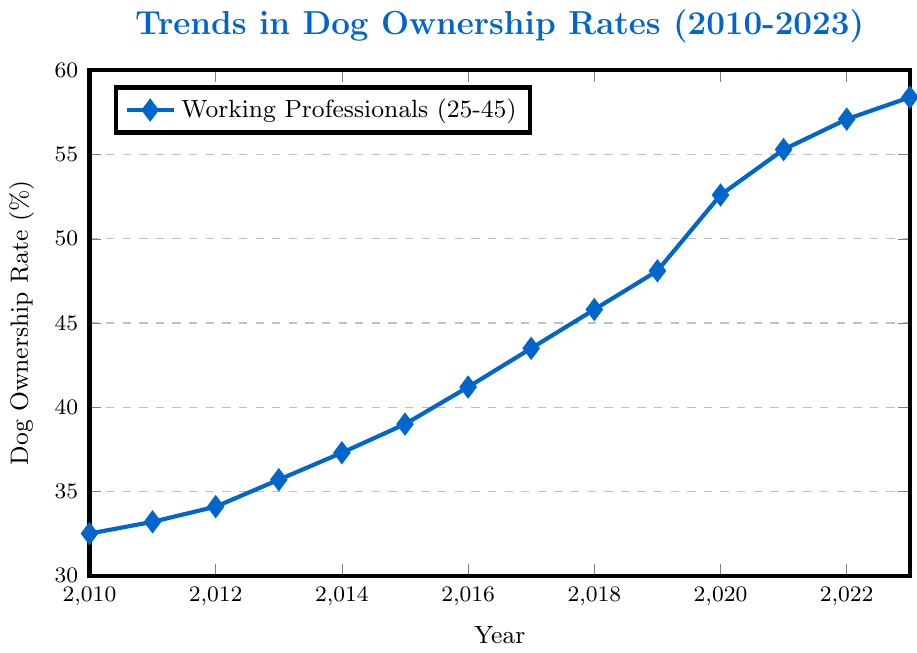what is the highest dog ownership rate recorded between 2010 and 2023? Looking at the y-axis (dog ownership rate) and finding the maximum value on the plotted line, the highest rate is 58.4% in 2023.
Answer: 58.4% Which year experienced the biggest increase in dog ownership rate compared to the previous year? Calculate the year-on-year differences: 33.2 - 32.5 = 0.7 (2010-2011), 34.1 - 33.2 = 0.9 (2011-2012), ..., 58.4 - 57.1 = 1.3 (2022-2023). The largest increase is from 2019 to 2020 with 52.6 - 48.1 = 4.5.
Answer: 2019-2020 How much did the dog ownership rate increase from 2010 to 2023? Subtract the value in 2010 from the value in 2023: 58.4 - 32.5.
Answer: 25.9 In which years did the dog ownership rate exceed 40%? Identify years where the plotted values exceed 40%: from 2016 onwards the values are above 40%.
Answer: 2016-2023 What is the average dog ownership rate over the entire period? Sum all values and divide by the number of years: (32.5 + 33.2 + 34.1 + 35.7 + 37.3 + 39.0 + 41.2 + 43.5 + 45.8 + 48.1 + 52.6 + 55.3 + 57.1 + 58.4) / 14.
Answer: 43.61% Between which consecutive years was the smallest increase in dog ownership rate recorded? Compute the year-on-year differences: 33.2 - 32.5 = 0.7 (2010-2011), 34.1 - 33.2 = 0.9 (2011-2012), ..., 58.4 - 57.1 = 1.3 (2022-2023). The smallest increase is from 2010 to 2011 with 32.5 to 33.2 = 0.7.
Answer: 2010-2011 Did the dog ownership rate rise steadily every year or were there any declines? By examining the plotted trend, the dog ownership rate increases with each passing year without any declines.
Answer: risen steadily How many times did the dog ownership rate increase by more than 2% year-on-year? Calculate the year-on-year differences and count those above 2%: 34.1 - 33.2 (0.9) is not more than 2%, ..., 52.6 - 48.1 (4.5) is more than 2%. Repeat for each pair of consecutive years. The years: 2012-2013, 2014-2015, 2015-2016, 2016-2017, 2017-2018, 2018-2019, 2019-2020, 2020-2021, 2021-2022, 2022-2023 each had increases more than 2%.
Answer: 10 Which year had the midpoint rate between the lowest and the highest recorded rates? The lowest rate is 32.5% (2010) and the highest is 58.4% (2023). Midpoint rate = (32.5 + 58.4) / 2 = 45.45%. In 2018, the rate is closest to 45.45%.
Answer: 2018 